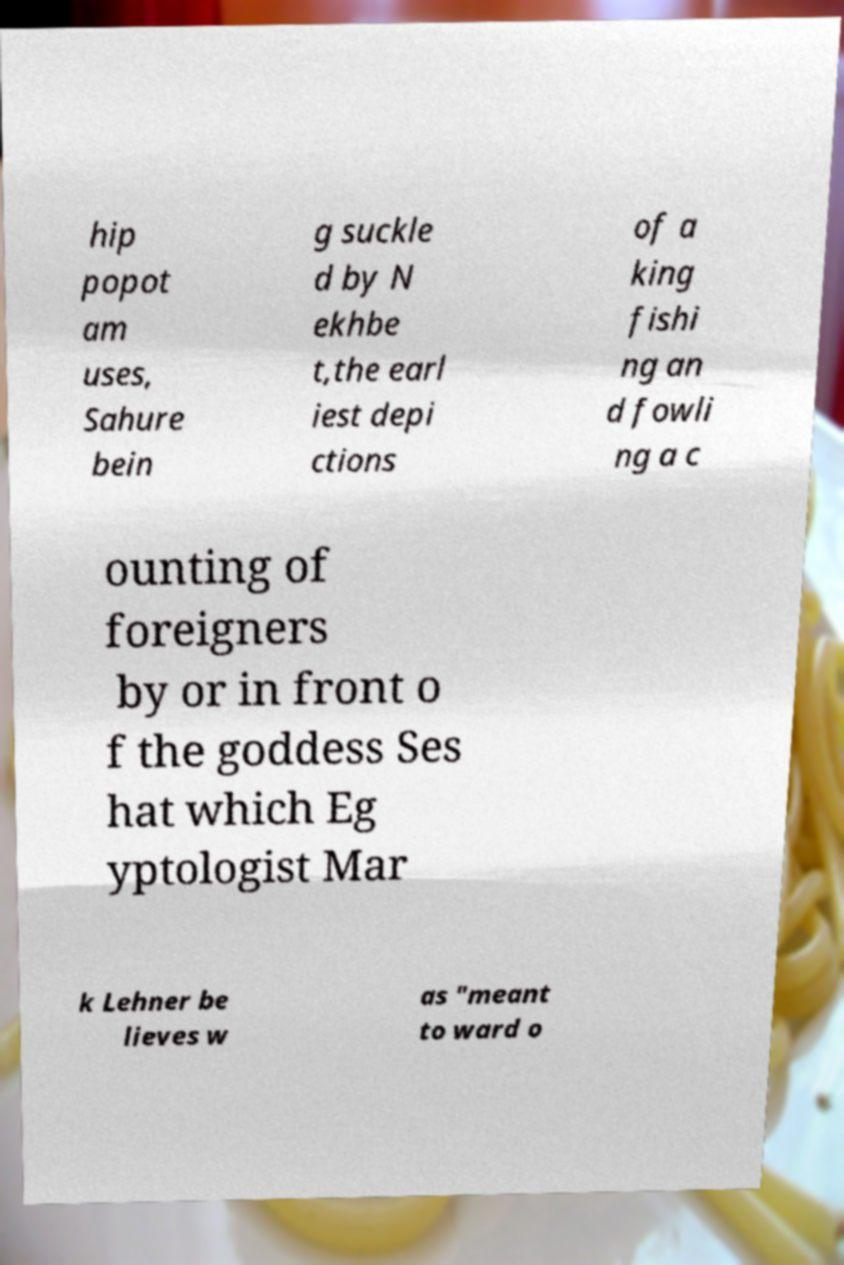Please read and relay the text visible in this image. What does it say? hip popot am uses, Sahure bein g suckle d by N ekhbe t,the earl iest depi ctions of a king fishi ng an d fowli ng a c ounting of foreigners by or in front o f the goddess Ses hat which Eg yptologist Mar k Lehner be lieves w as "meant to ward o 